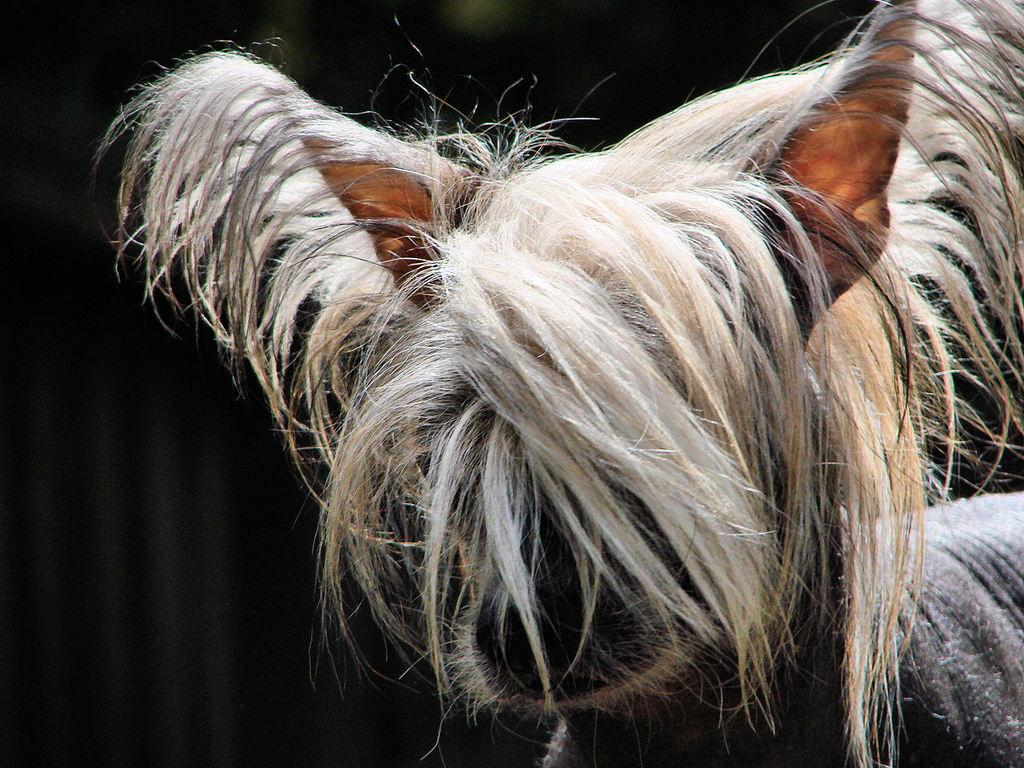What type of living creature is present in the image? There is an animal in the image. Can you describe the background of the image? The background of the image is dark. What year was the art piece created in the image? There is no indication that the image is an art piece, and no year is mentioned or implied in the provided facts. 